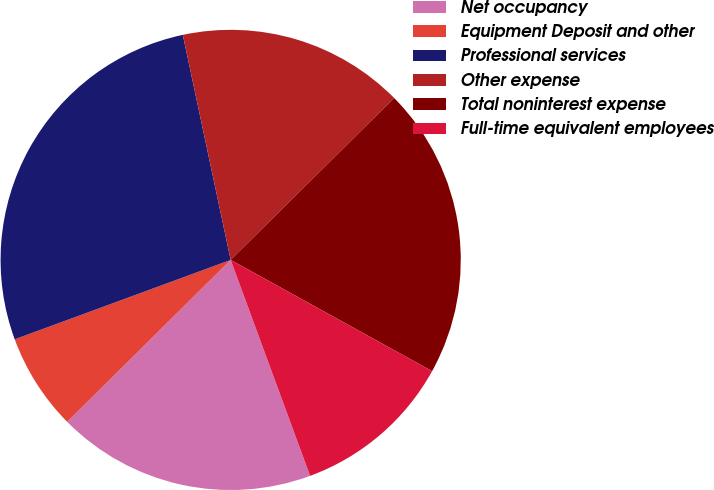<chart> <loc_0><loc_0><loc_500><loc_500><pie_chart><fcel>Net occupancy<fcel>Equipment Deposit and other<fcel>Professional services<fcel>Other expense<fcel>Total noninterest expense<fcel>Full-time equivalent employees<nl><fcel>18.18%<fcel>6.82%<fcel>27.27%<fcel>15.91%<fcel>20.45%<fcel>11.36%<nl></chart> 